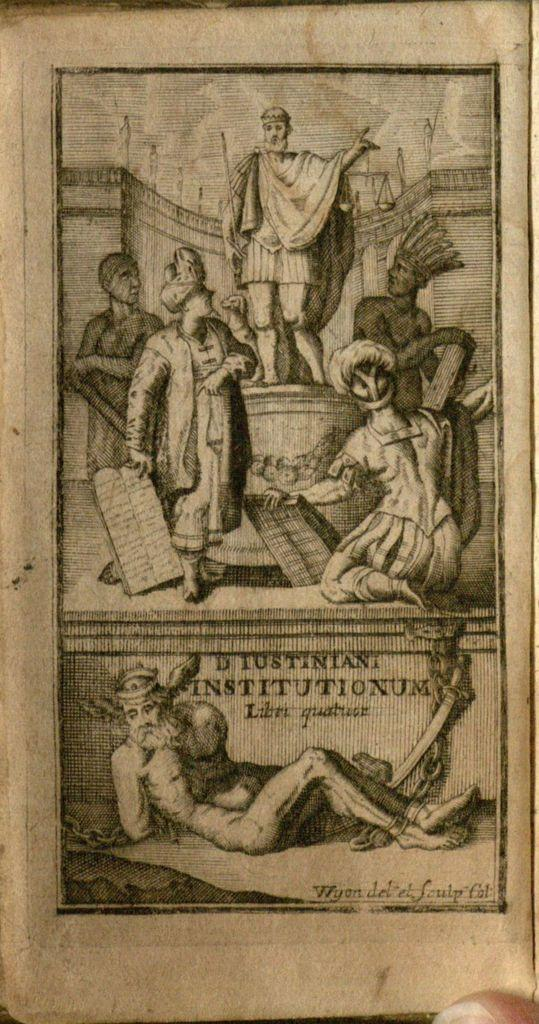What is present in the image? There is a paper in the image. Can you describe the paper in the image? The paper appears to be flat and rectangular. What might the paper be used for? The paper could be used for writing, drawing, or printing. What type of cake is being eaten by the person in the image? There is no person or cake present in the image; it only contains a paper. 